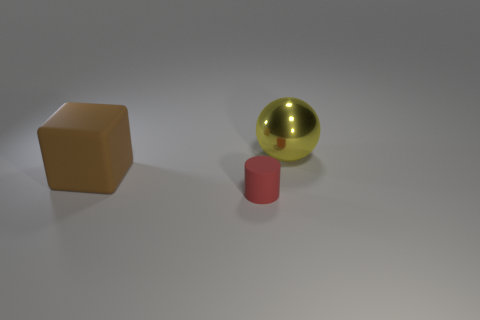Is there anything else that has the same size as the cylinder?
Your response must be concise. No. Is there a brown cube of the same size as the metallic thing?
Provide a short and direct response. Yes. There is a large brown cube behind the matte thing that is to the right of the large thing that is in front of the big sphere; what is its material?
Offer a terse response. Rubber. There is a big object right of the cube; what number of small red cylinders are behind it?
Keep it short and to the point. 0. There is a matte object to the right of the rubber cube; is it the same size as the yellow metallic sphere?
Offer a terse response. No. How many other large metallic things have the same shape as the shiny object?
Make the answer very short. 0. What is the shape of the large yellow object?
Ensure brevity in your answer.  Sphere. Are there an equal number of shiny objects behind the brown matte cube and big balls?
Offer a terse response. Yes. Is there any other thing that has the same material as the brown cube?
Your answer should be compact. Yes. Are the big object that is left of the yellow shiny thing and the big yellow object made of the same material?
Provide a short and direct response. No. 